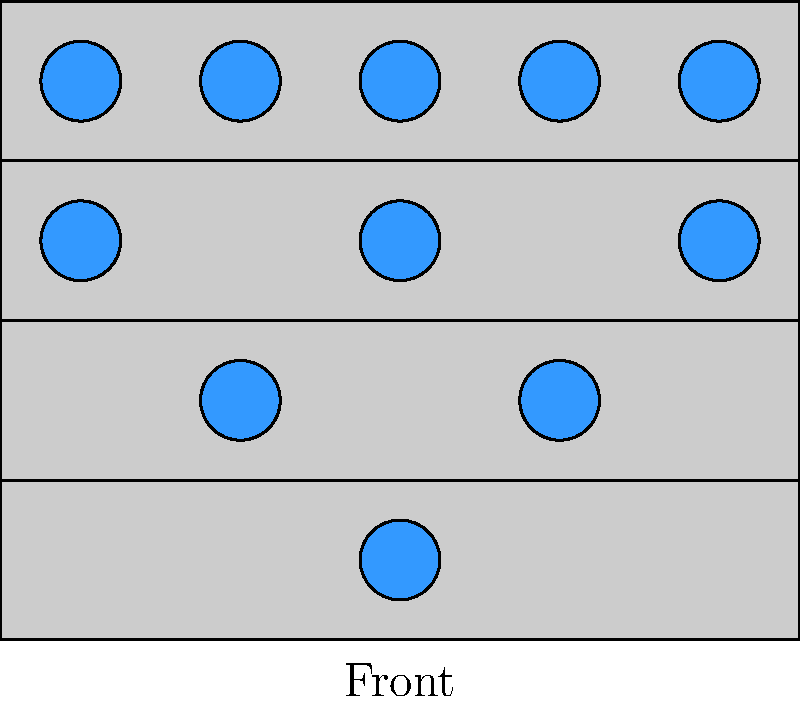As a soprano, you're arranging the choir on risers for optimal sound projection. The diagram shows a possible arrangement with 4 rows. How many singers are there in total, and what formation principle is being used to maximize sound output? To answer this question, let's analyze the diagram step-by-step:

1. Count the singers in each row:
   - Bottom row (front): 1 singer
   - Second row: 2 singers
   - Third row: 3 singers
   - Top row (back): 5 singers

2. Calculate the total number of singers:
   $1 + 2 + 3 + 5 = 11$ singers in total

3. Observe the formation principle:
   - The number of singers increases as we move to higher rows
   - Singers are positioned in a staggered formation
   - This arrangement allows for better visibility and sound projection

4. Identify the formation principle:
   The choir is arranged in a triangular or pyramid formation. This setup is known as the "Pyramid Formation" in choral arrangements.

5. Understand the benefits of this formation:
   - Allows all singers to be seen and heard
   - Helps blend voices more effectively
   - Improves overall sound projection to the audience

Therefore, there are 11 singers in total, arranged in a Pyramid Formation to maximize sound output and visual presentation.
Answer: 11 singers; Pyramid Formation 